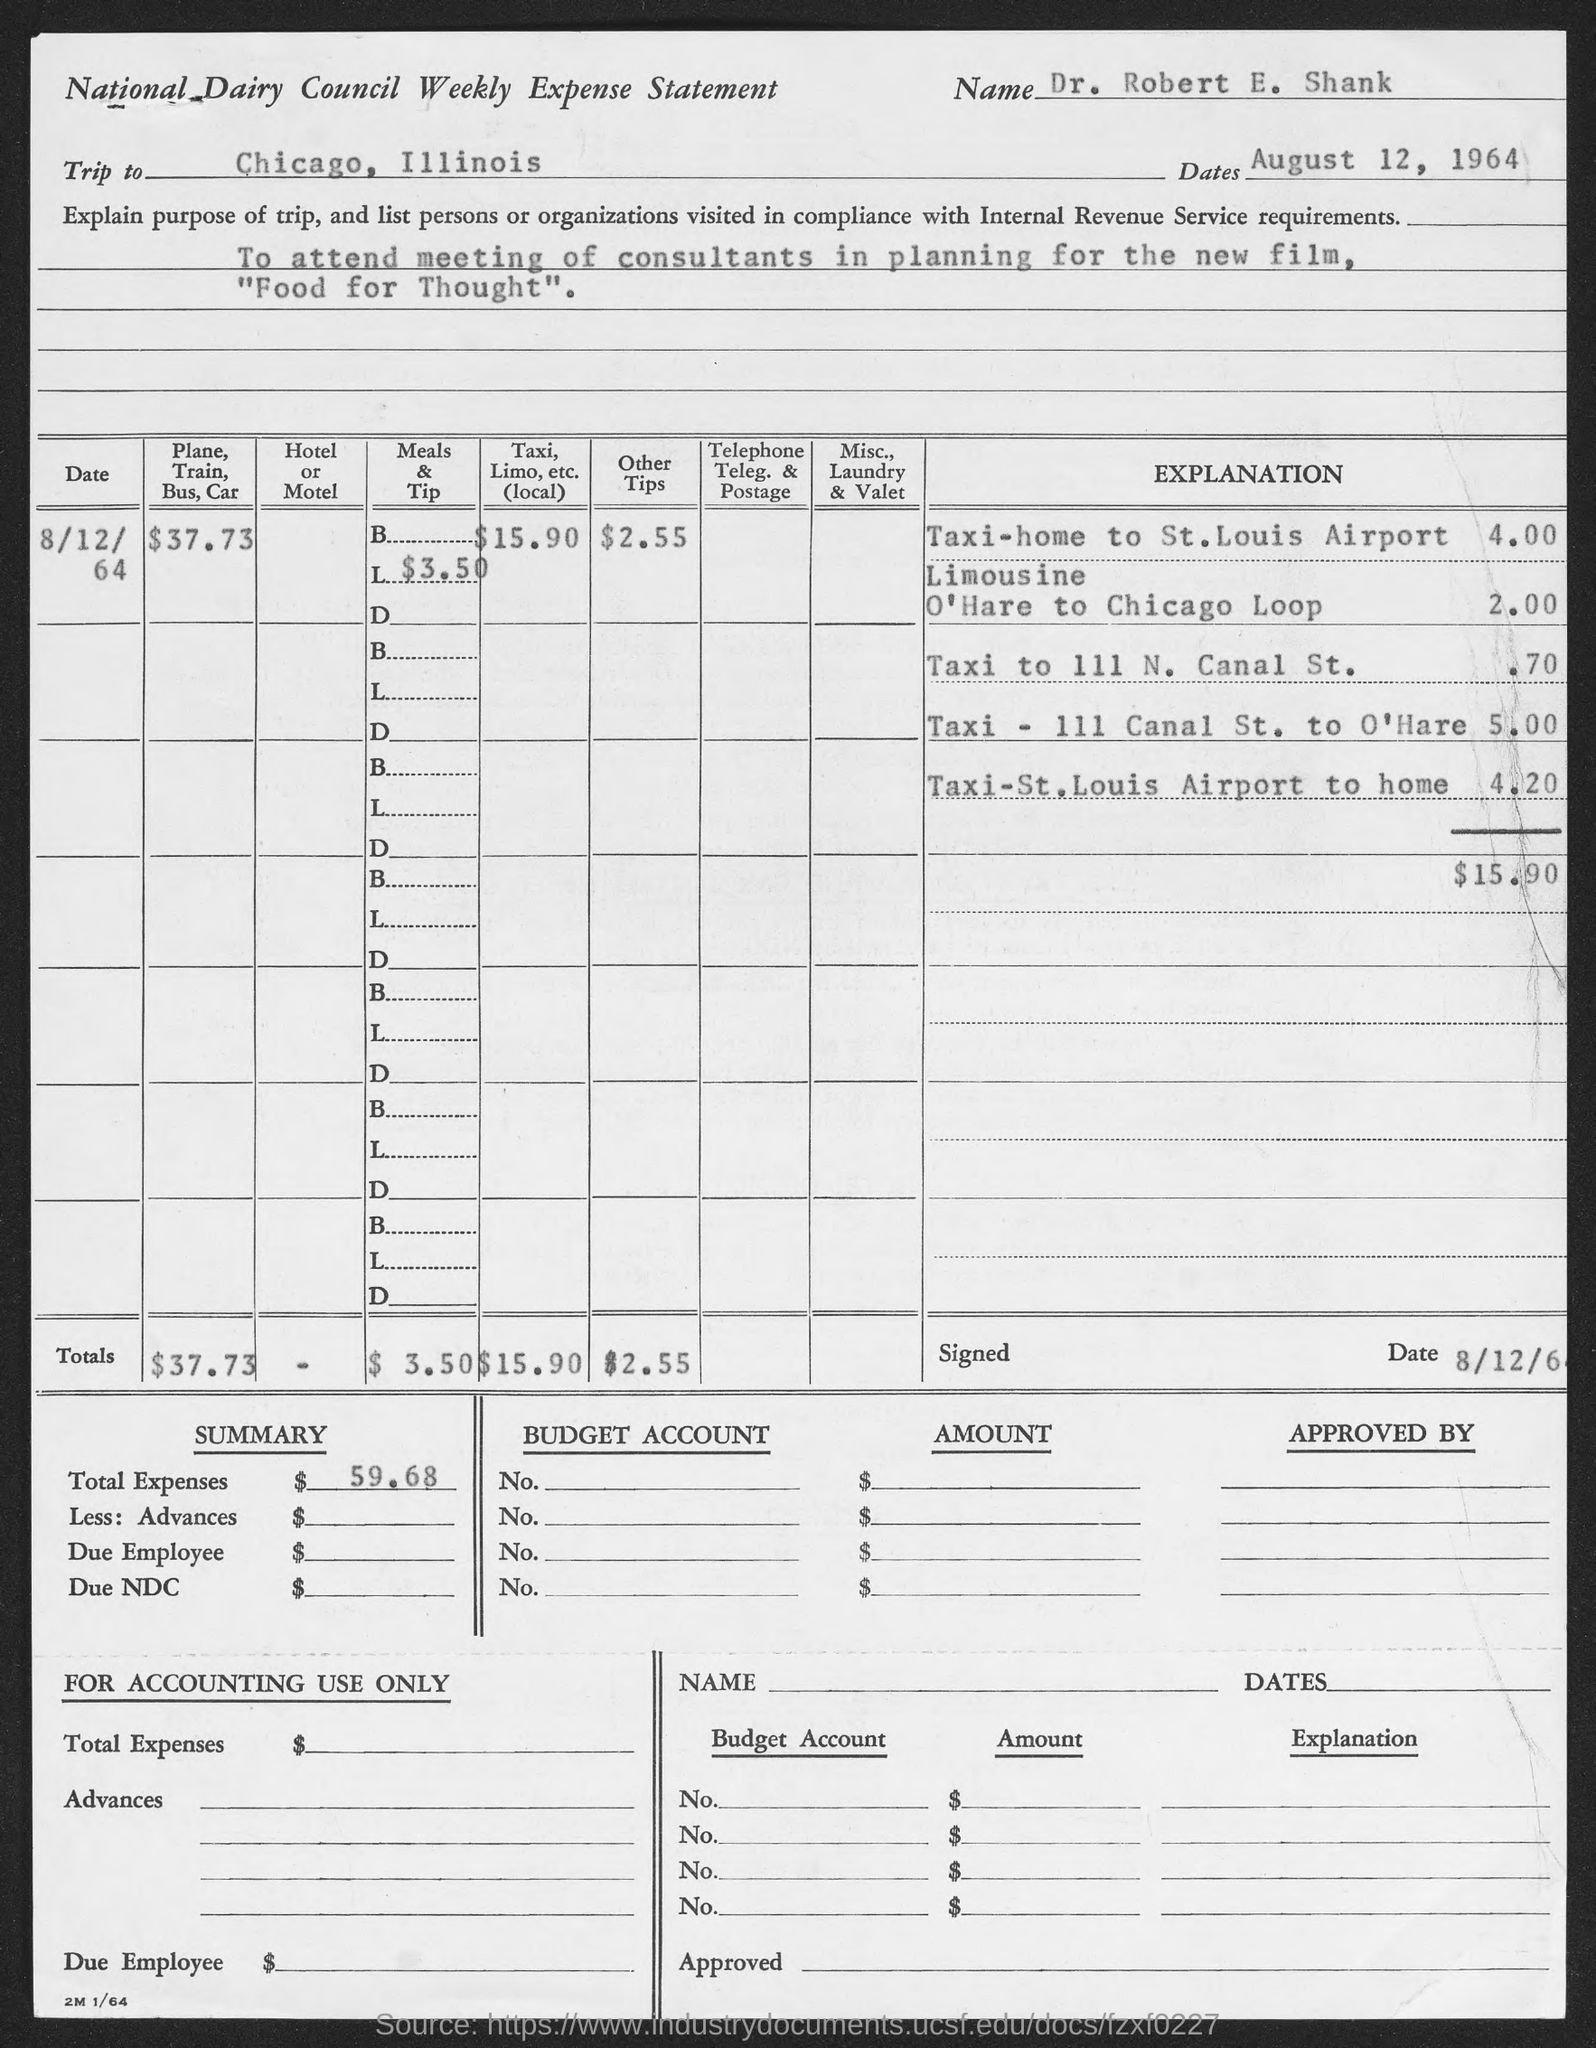Give some essential details in this illustration. The destination of the trip is Chicago, Illinois. The total amount for "Other Tips" is $2.55. Dr. Robert E. Shank is the name given to a person. The form is about the National Dairy Council and its weekly expenses. The date given is August 12, 1964. 